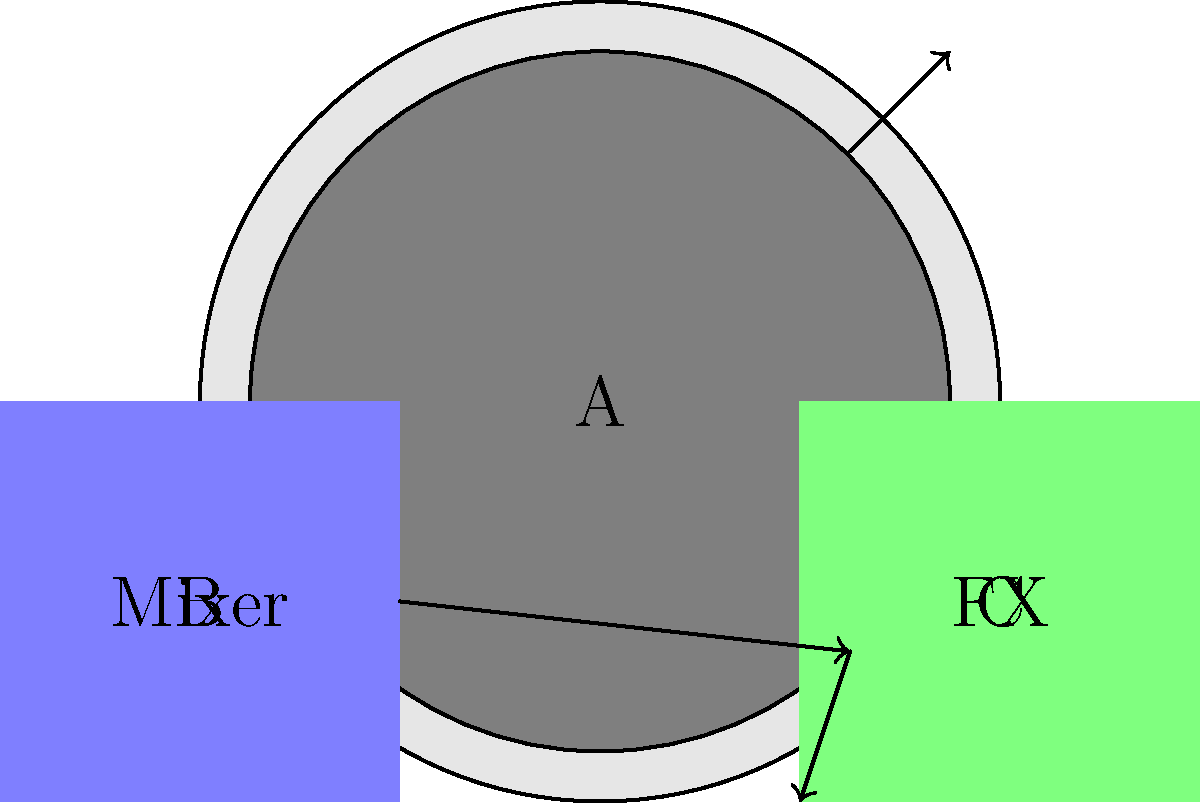In this diagram of a typical 90s Dutch dance DJ setup, what is the correct signal flow from the turntable (A) through the other components? To determine the correct signal flow in this 90s Dutch dance DJ setup, we need to analyze the diagram and understand the typical setup used by DJs during that era. Let's break it down step-by-step:

1. The diagram shows three main components:
   A: Turntable
   B: Mixer
   C: Effects unit (FX)

2. In a typical DJ setup, the signal flow usually starts from the turntable, as this is where the music source (vinyl record) is played.

3. The arrow from the turntable (A) points towards the mixer (B). This indicates that the audio signal first goes from the turntable to the mixer.

4. From the mixer (B), we see an arrow pointing towards the effects unit (C). This suggests that the signal then travels from the mixer to the effects unit.

5. The final arrow shows the signal returning from the effects unit (C) back to the mixer (B).

This setup allows the DJ to:
- Play the record on the turntable
- Control volume and EQ on the mixer
- Add effects to the music using the effects unit
- Mix the effected signal back into the main output through the mixer

Therefore, the correct signal flow is: Turntable (A) → Mixer (B) → Effects unit (C) → Mixer (B)
Answer: A → B → C → B 